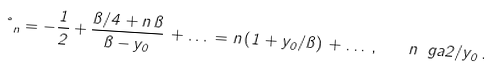Convert formula to latex. <formula><loc_0><loc_0><loc_500><loc_500>\nu _ { n } = - \frac { 1 } { 2 } + \frac { \pi / 4 + n \, \pi } { \pi - y _ { 0 } } \, + \dots \, = n \left ( 1 + y _ { 0 } / \pi \right ) \, + \dots \, , \quad n \ g a 2 / y _ { 0 } \, .</formula> 